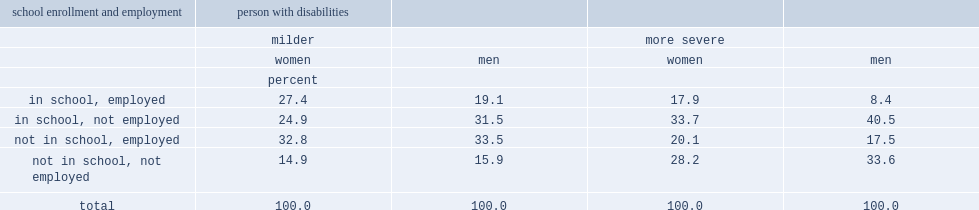Among those people neither in school nor employed, what is the ratio of people aged 15 to 24 years with more severe disabilities to those with milder disabilities regardless of their gender? 1.892617 2.113208. For those in 15-24 age group who were in school, which group of people was more likely to also be employed during their school enrolment? female or male? Women. For those with more severe disabilities aged 15 to 24 years who were in school, how many times of young women compared to young men have they been employed? 2.130952. Among youth with milder disabilities who were in school, what percent of the women were also employed, compared to 38% of young men? 0.523901. 